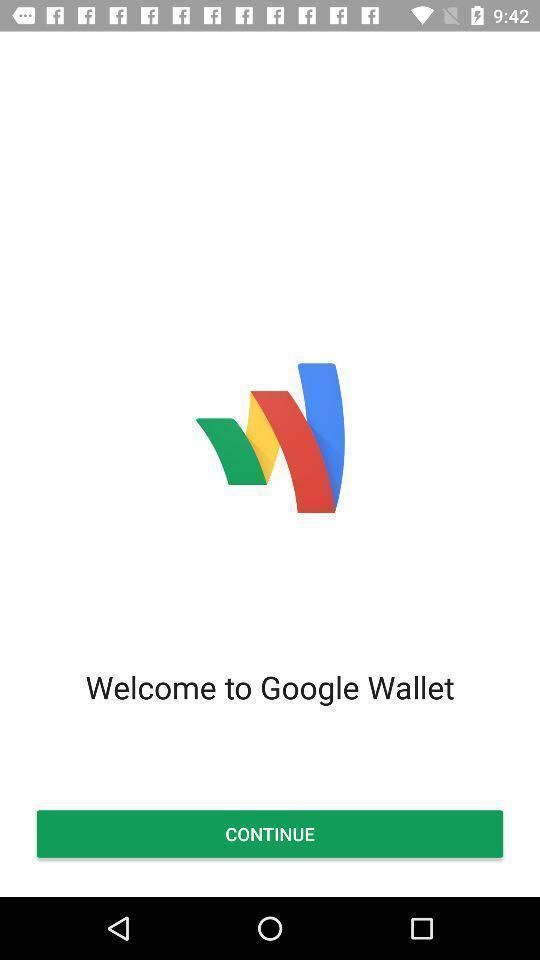Please provide a description for this image. Welcome page to the application with continue option. 